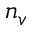<formula> <loc_0><loc_0><loc_500><loc_500>n _ { v }</formula> 